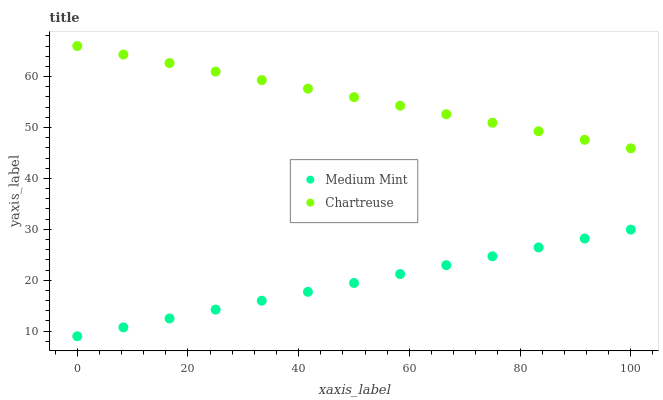Does Medium Mint have the minimum area under the curve?
Answer yes or no. Yes. Does Chartreuse have the maximum area under the curve?
Answer yes or no. Yes. Does Chartreuse have the minimum area under the curve?
Answer yes or no. No. Is Medium Mint the smoothest?
Answer yes or no. Yes. Is Chartreuse the roughest?
Answer yes or no. Yes. Is Chartreuse the smoothest?
Answer yes or no. No. Does Medium Mint have the lowest value?
Answer yes or no. Yes. Does Chartreuse have the lowest value?
Answer yes or no. No. Does Chartreuse have the highest value?
Answer yes or no. Yes. Is Medium Mint less than Chartreuse?
Answer yes or no. Yes. Is Chartreuse greater than Medium Mint?
Answer yes or no. Yes. Does Medium Mint intersect Chartreuse?
Answer yes or no. No. 